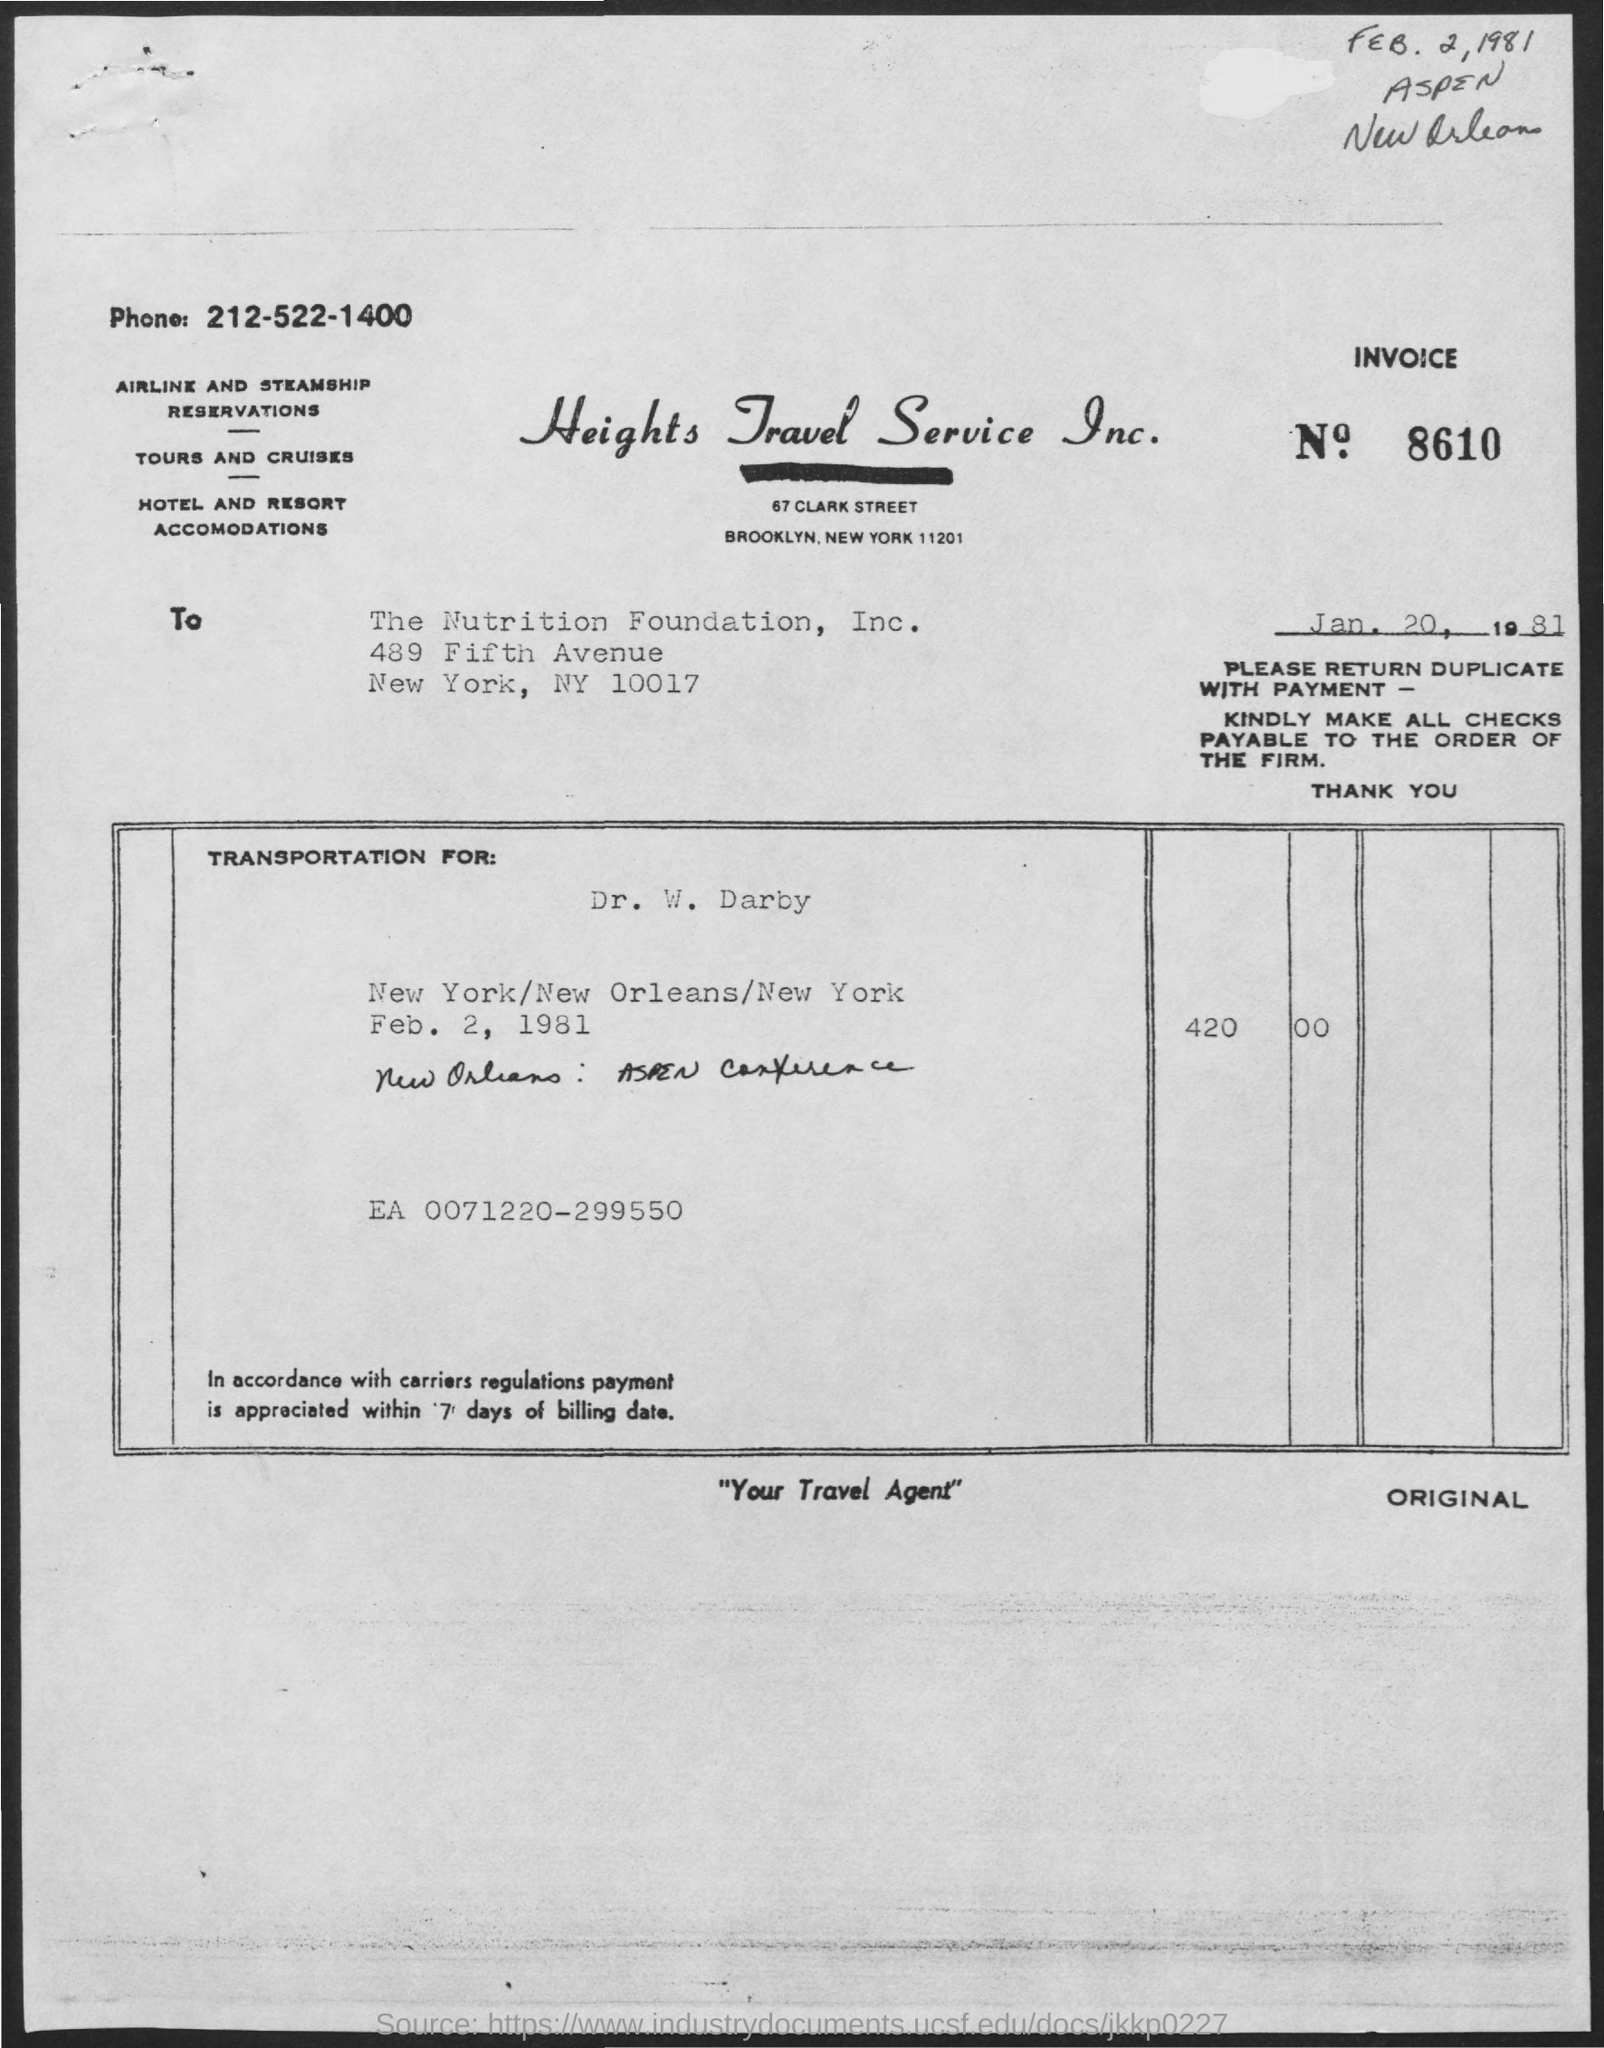What is the Invoice Number?
Your answer should be compact. 8610. What is the date below the invoice number?
Offer a very short reply. Jan. 20, 1981. What is the handwritten date at the top right of the document?
Your response must be concise. Feb. 2, 1981. 